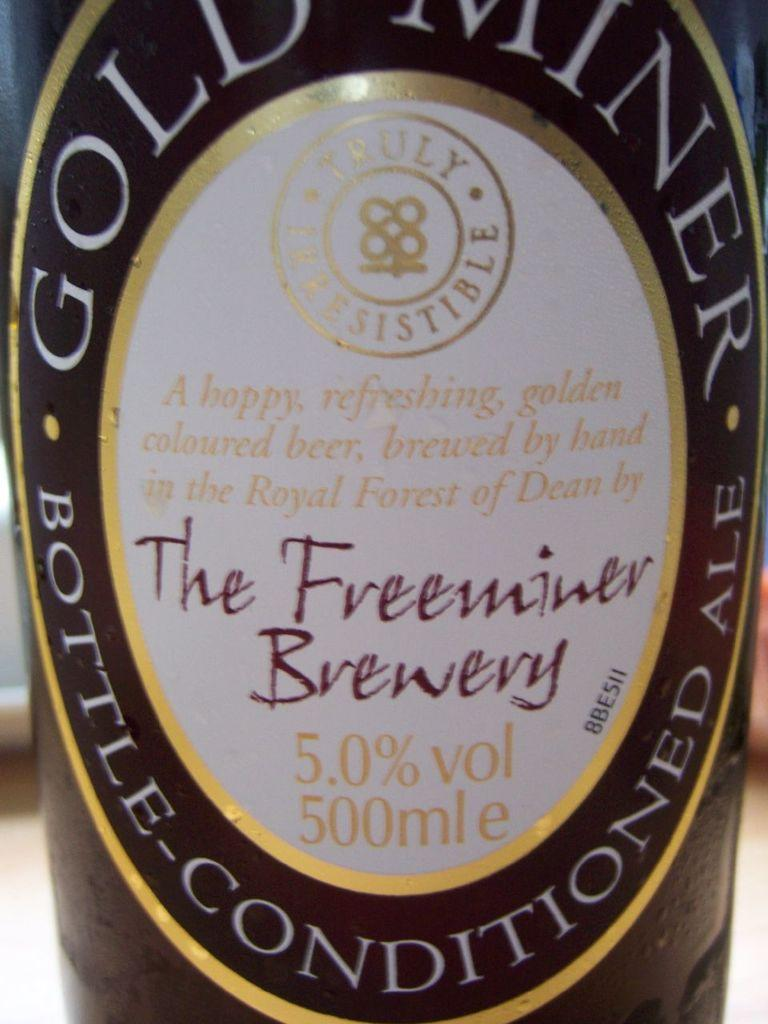<image>
Present a compact description of the photo's key features. The Freeminer Brewery made this bottle of beer. 